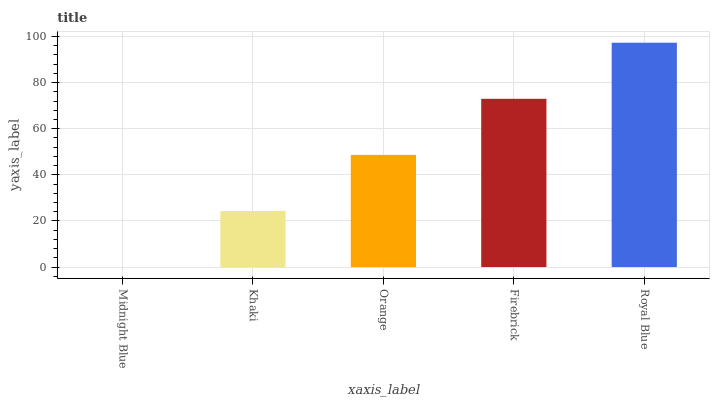Is Midnight Blue the minimum?
Answer yes or no. Yes. Is Royal Blue the maximum?
Answer yes or no. Yes. Is Khaki the minimum?
Answer yes or no. No. Is Khaki the maximum?
Answer yes or no. No. Is Khaki greater than Midnight Blue?
Answer yes or no. Yes. Is Midnight Blue less than Khaki?
Answer yes or no. Yes. Is Midnight Blue greater than Khaki?
Answer yes or no. No. Is Khaki less than Midnight Blue?
Answer yes or no. No. Is Orange the high median?
Answer yes or no. Yes. Is Orange the low median?
Answer yes or no. Yes. Is Royal Blue the high median?
Answer yes or no. No. Is Midnight Blue the low median?
Answer yes or no. No. 